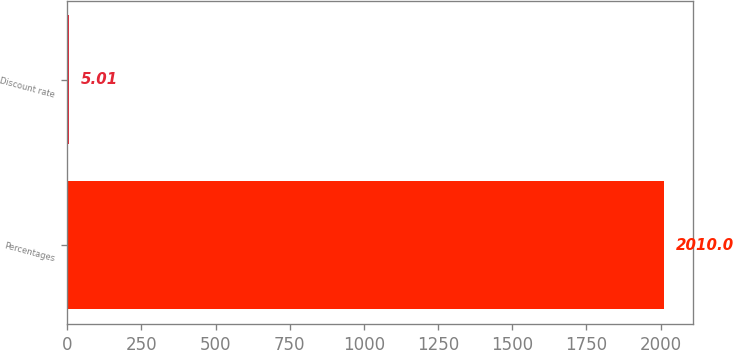Convert chart to OTSL. <chart><loc_0><loc_0><loc_500><loc_500><bar_chart><fcel>Percentages<fcel>Discount rate<nl><fcel>2010<fcel>5.01<nl></chart> 